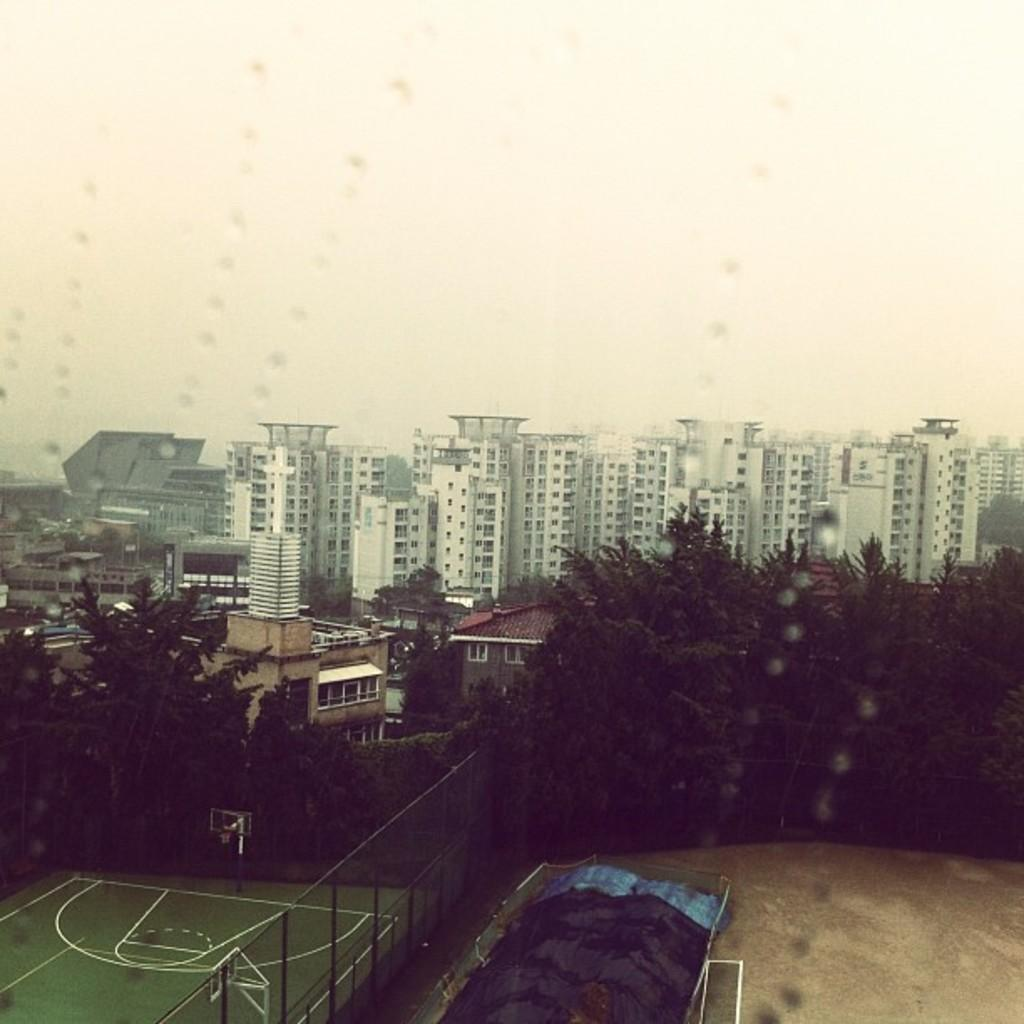What type of sports facility is visible in the image? There is a basketball court in the image. What is located near the basketball court? The basketball court is near a fencing. What can be seen on the right side of the image? There is a ground on the right side of the image. What is visible in the background of the image? There are trees, buildings with glass windows, and the sky in the background of the image. What color is the scarf that the basketball player is wearing in the image? There are no basketball players or scarves present in the image. What type of ink is used to write the score on the basketball court? There is no writing or score visible on the basketball court in the image. 